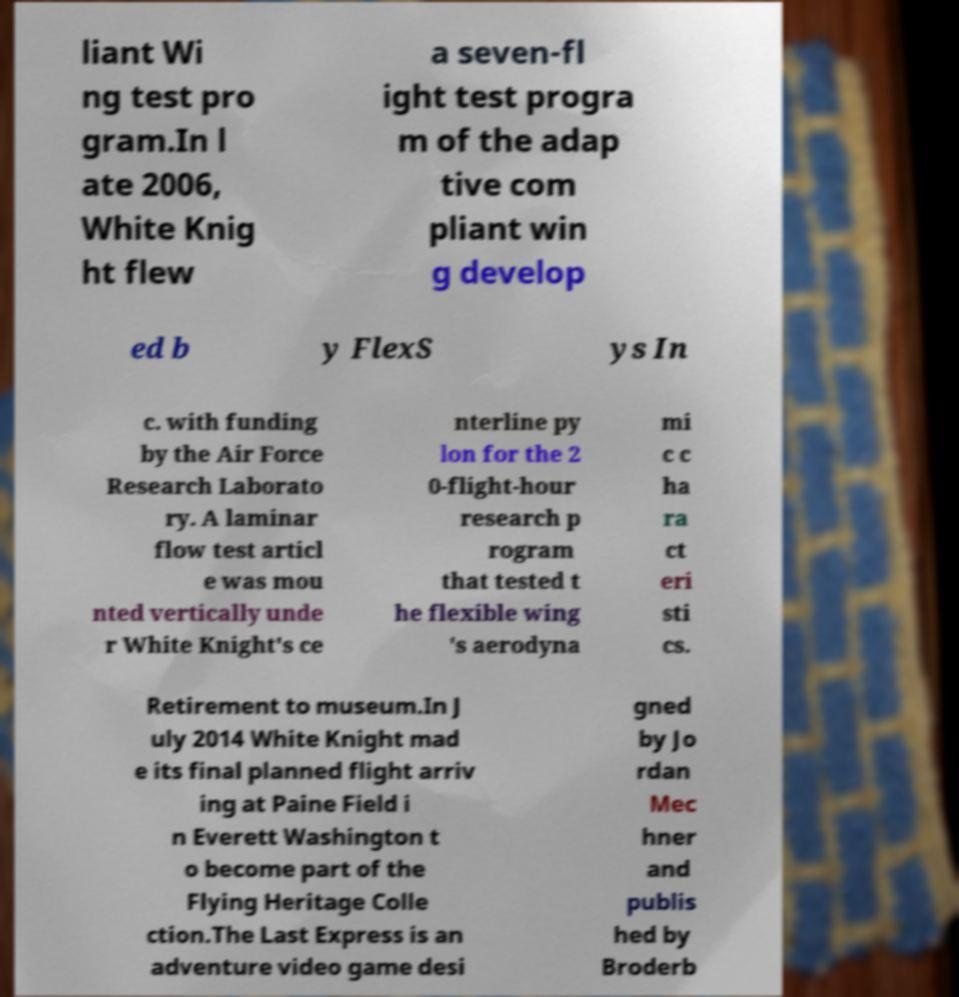There's text embedded in this image that I need extracted. Can you transcribe it verbatim? liant Wi ng test pro gram.In l ate 2006, White Knig ht flew a seven-fl ight test progra m of the adap tive com pliant win g develop ed b y FlexS ys In c. with funding by the Air Force Research Laborato ry. A laminar flow test articl e was mou nted vertically unde r White Knight's ce nterline py lon for the 2 0-flight-hour research p rogram that tested t he flexible wing 's aerodyna mi c c ha ra ct eri sti cs. Retirement to museum.In J uly 2014 White Knight mad e its final planned flight arriv ing at Paine Field i n Everett Washington t o become part of the Flying Heritage Colle ction.The Last Express is an adventure video game desi gned by Jo rdan Mec hner and publis hed by Broderb 